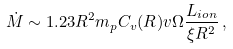Convert formula to latex. <formula><loc_0><loc_0><loc_500><loc_500>\dot { M } \sim 1 . 2 3 R ^ { 2 } m _ { p } { C _ { v } } { ( R ) } v \Omega \frac { L _ { i o n } } { { \xi } R ^ { 2 } } \, ,</formula> 